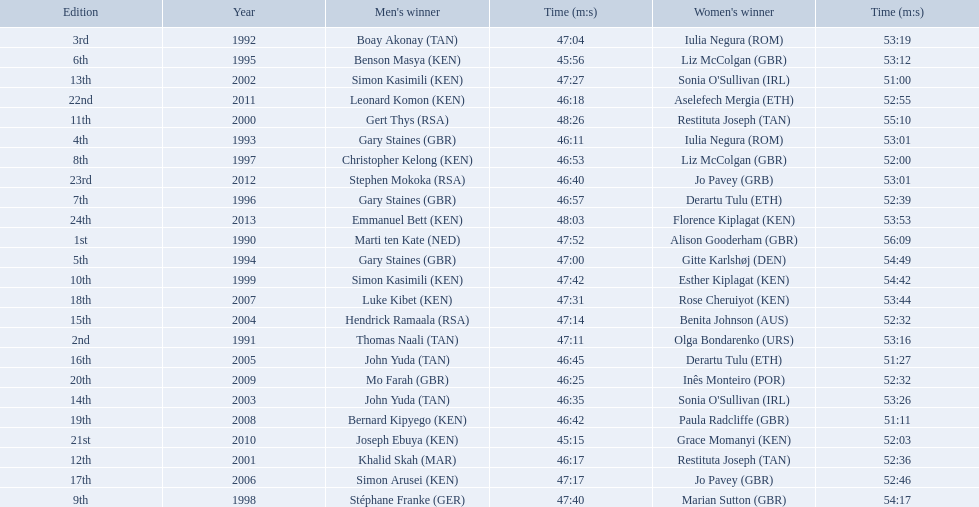Which of the runner in the great south run were women? Alison Gooderham (GBR), Olga Bondarenko (URS), Iulia Negura (ROM), Iulia Negura (ROM), Gitte Karlshøj (DEN), Liz McColgan (GBR), Derartu Tulu (ETH), Liz McColgan (GBR), Marian Sutton (GBR), Esther Kiplagat (KEN), Restituta Joseph (TAN), Restituta Joseph (TAN), Sonia O'Sullivan (IRL), Sonia O'Sullivan (IRL), Benita Johnson (AUS), Derartu Tulu (ETH), Jo Pavey (GBR), Rose Cheruiyot (KEN), Paula Radcliffe (GBR), Inês Monteiro (POR), Grace Momanyi (KEN), Aselefech Mergia (ETH), Jo Pavey (GRB), Florence Kiplagat (KEN). Of those women, which ones had a time of at least 53 minutes? Alison Gooderham (GBR), Olga Bondarenko (URS), Iulia Negura (ROM), Iulia Negura (ROM), Gitte Karlshøj (DEN), Liz McColgan (GBR), Marian Sutton (GBR), Esther Kiplagat (KEN), Restituta Joseph (TAN), Sonia O'Sullivan (IRL), Rose Cheruiyot (KEN), Jo Pavey (GRB), Florence Kiplagat (KEN). Between those women, which ones did not go over 53 minutes? Olga Bondarenko (URS), Iulia Negura (ROM), Iulia Negura (ROM), Liz McColgan (GBR), Sonia O'Sullivan (IRL), Rose Cheruiyot (KEN), Jo Pavey (GRB), Florence Kiplagat (KEN). Of those 8, what were the three slowest times? Sonia O'Sullivan (IRL), Rose Cheruiyot (KEN), Florence Kiplagat (KEN). Between only those 3 women, which runner had the fastest time? Sonia O'Sullivan (IRL). What was this women's time? 53:26. 